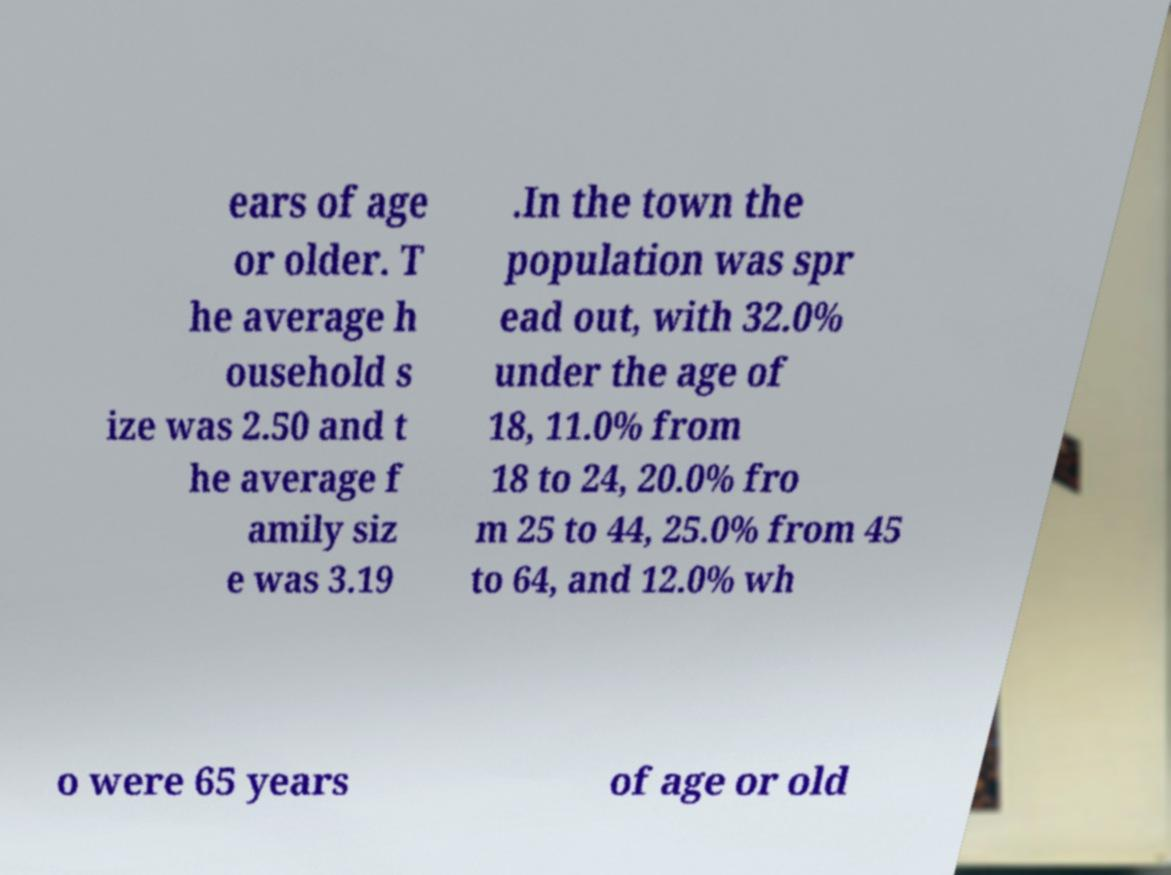Can you read and provide the text displayed in the image?This photo seems to have some interesting text. Can you extract and type it out for me? ears of age or older. T he average h ousehold s ize was 2.50 and t he average f amily siz e was 3.19 .In the town the population was spr ead out, with 32.0% under the age of 18, 11.0% from 18 to 24, 20.0% fro m 25 to 44, 25.0% from 45 to 64, and 12.0% wh o were 65 years of age or old 